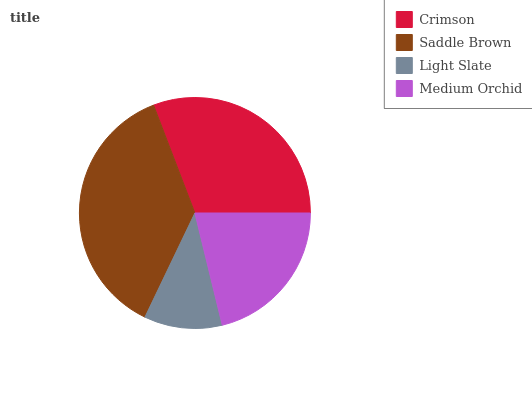Is Light Slate the minimum?
Answer yes or no. Yes. Is Saddle Brown the maximum?
Answer yes or no. Yes. Is Saddle Brown the minimum?
Answer yes or no. No. Is Light Slate the maximum?
Answer yes or no. No. Is Saddle Brown greater than Light Slate?
Answer yes or no. Yes. Is Light Slate less than Saddle Brown?
Answer yes or no. Yes. Is Light Slate greater than Saddle Brown?
Answer yes or no. No. Is Saddle Brown less than Light Slate?
Answer yes or no. No. Is Crimson the high median?
Answer yes or no. Yes. Is Medium Orchid the low median?
Answer yes or no. Yes. Is Medium Orchid the high median?
Answer yes or no. No. Is Crimson the low median?
Answer yes or no. No. 